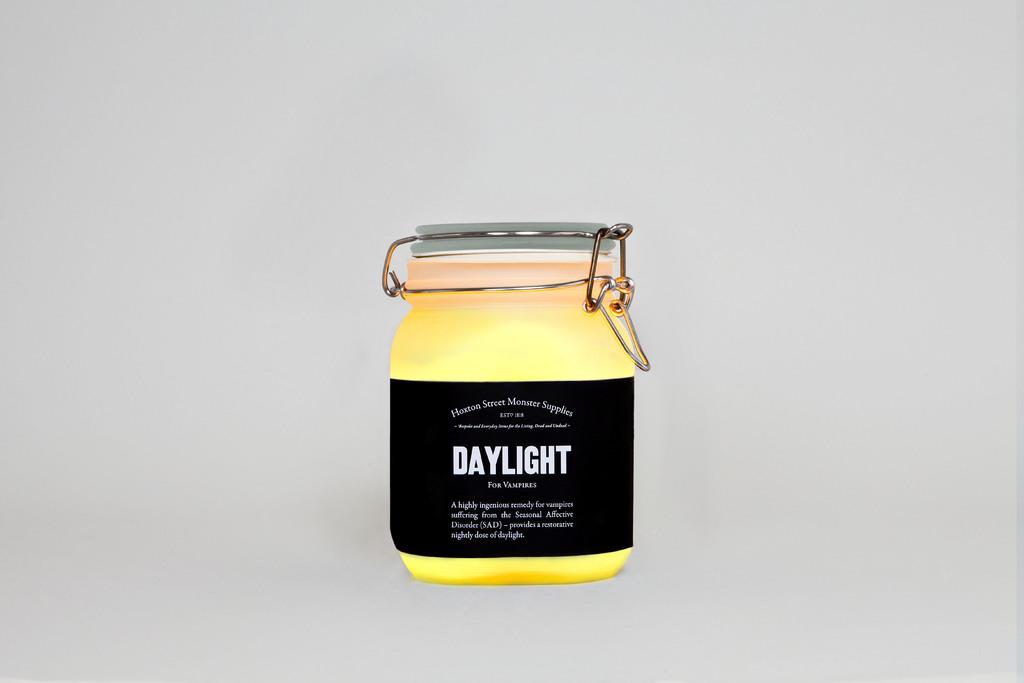What brand is the candle?
Your response must be concise. Daylight. 